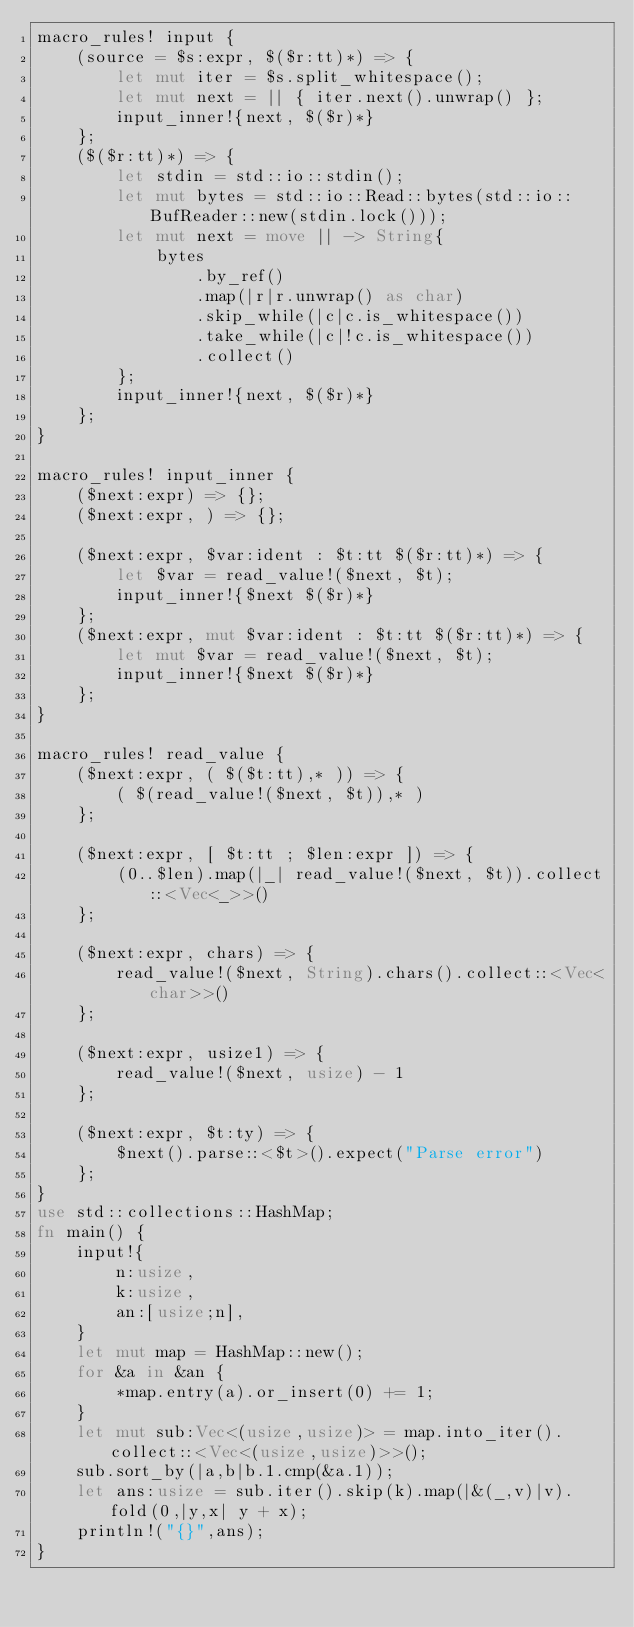<code> <loc_0><loc_0><loc_500><loc_500><_Rust_>macro_rules! input {
    (source = $s:expr, $($r:tt)*) => {
        let mut iter = $s.split_whitespace();
        let mut next = || { iter.next().unwrap() };
        input_inner!{next, $($r)*}
    };
    ($($r:tt)*) => {
        let stdin = std::io::stdin();
        let mut bytes = std::io::Read::bytes(std::io::BufReader::new(stdin.lock()));
        let mut next = move || -> String{
            bytes
                .by_ref()
                .map(|r|r.unwrap() as char)
                .skip_while(|c|c.is_whitespace())
                .take_while(|c|!c.is_whitespace())
                .collect()
        };
        input_inner!{next, $($r)*}
    };
}

macro_rules! input_inner {
    ($next:expr) => {};
    ($next:expr, ) => {};

    ($next:expr, $var:ident : $t:tt $($r:tt)*) => {
        let $var = read_value!($next, $t);
        input_inner!{$next $($r)*}
    };
    ($next:expr, mut $var:ident : $t:tt $($r:tt)*) => {
        let mut $var = read_value!($next, $t);
        input_inner!{$next $($r)*}
    };
}

macro_rules! read_value {
    ($next:expr, ( $($t:tt),* )) => {
        ( $(read_value!($next, $t)),* )
    };

    ($next:expr, [ $t:tt ; $len:expr ]) => {
        (0..$len).map(|_| read_value!($next, $t)).collect::<Vec<_>>()
    };

    ($next:expr, chars) => {
        read_value!($next, String).chars().collect::<Vec<char>>()
    };

    ($next:expr, usize1) => {
        read_value!($next, usize) - 1
    };

    ($next:expr, $t:ty) => {
        $next().parse::<$t>().expect("Parse error")
    };
}
use std::collections::HashMap;
fn main() {
    input!{
        n:usize,
        k:usize,
        an:[usize;n],
    }
    let mut map = HashMap::new();
    for &a in &an {
        *map.entry(a).or_insert(0) += 1;
    }
    let mut sub:Vec<(usize,usize)> = map.into_iter().collect::<Vec<(usize,usize)>>();
    sub.sort_by(|a,b|b.1.cmp(&a.1));
    let ans:usize = sub.iter().skip(k).map(|&(_,v)|v).fold(0,|y,x| y + x);
    println!("{}",ans);
}
</code> 